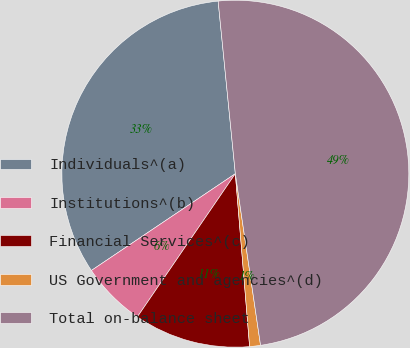Convert chart. <chart><loc_0><loc_0><loc_500><loc_500><pie_chart><fcel>Individuals^(a)<fcel>Institutions^(b)<fcel>Financial Services^(c)<fcel>US Government and agencies^(d)<fcel>Total on-balance sheet<nl><fcel>32.84%<fcel>6.03%<fcel>10.86%<fcel>1.01%<fcel>49.26%<nl></chart> 